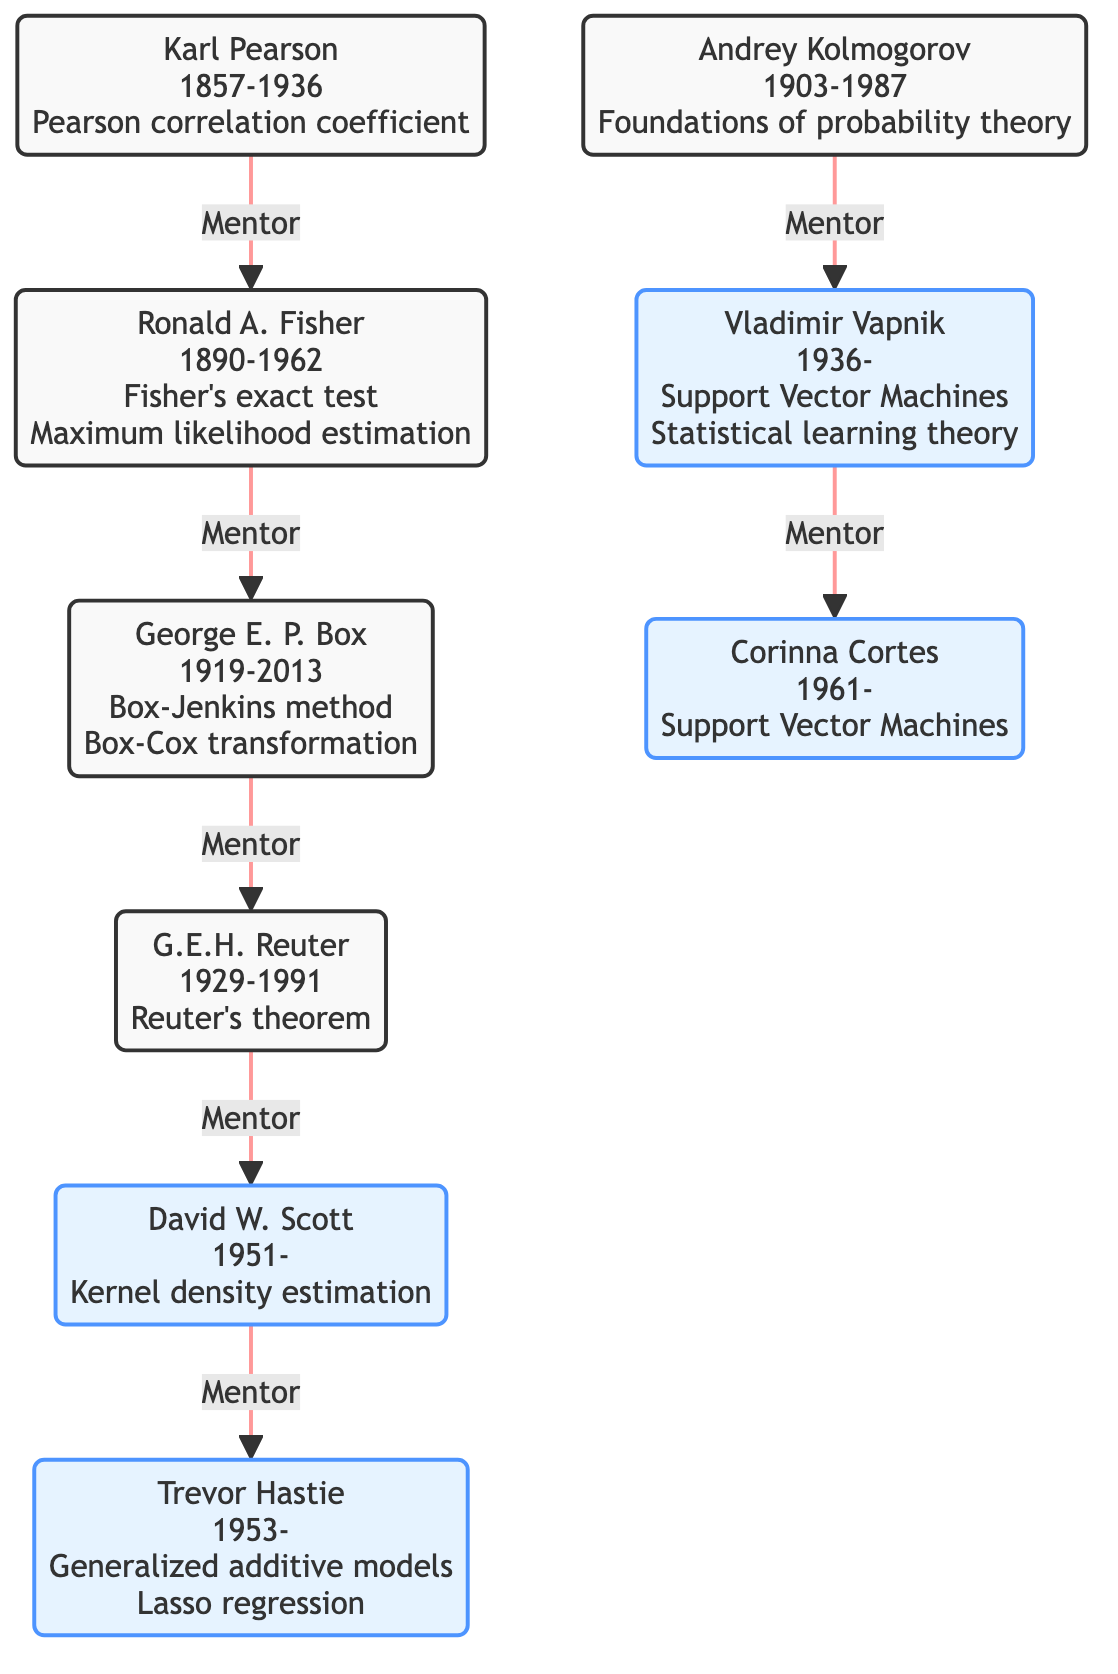What is the birth year of Ronald A. Fisher? Referring to the node for Ronald A. Fisher in the diagram, his birth year is stated as 1890.
Answer: 1890 Who mentored David W. Scott? By tracing the connections in the diagram, it is clear that George E. P. Box is identified as the mentor of David W. Scott.
Answer: George E. P. Box How many individuals influenced Corinna Cortes? Looking at the node for Corinna Cortes in the diagram, it is evident that she does not have any influences listed, indicating a count of zero.
Answer: 0 What contribution is associated with Andrey Kolmogorov? Examining the node for Andrey Kolmogorov, it highlights the contribution as "Foundations of probability theory."
Answer: Foundations of probability theory Which mentor connection leads to Trevor Hastie? Analyzing the connections, David W. Scott is the mentor who leads to Trevor Hastie in the diagram.
Answer: David W. Scott Who is the earliest born individual in the diagram? By comparing the birth years of all individuals listed in the diagram, Karl Pearson, born in 1857, is identified as the earliest born individual.
Answer: Karl Pearson What is the last contribution listed in the diagram? Upon reviewing the contributions noted within the nodes, the last contribution listed belongs to Corinna Cortes as "Support Vector Machines."
Answer: Support Vector Machines How many generations of mentorship can be traced from Karl Pearson to Trevor Hastie? Analyzing the mentorship connections, there are five links: Karl Pearson → Ronald A. Fisher → George E. P. Box → G.E.H. Reuter → David W. Scott → Trevor Hastie, resulting in five generations.
Answer: 5 Who influenced G.E.H. Reuter? Looking at the node for G.E.H. Reuter, David W. Scott is noted as the individual influenced by him.
Answer: David W. Scott 